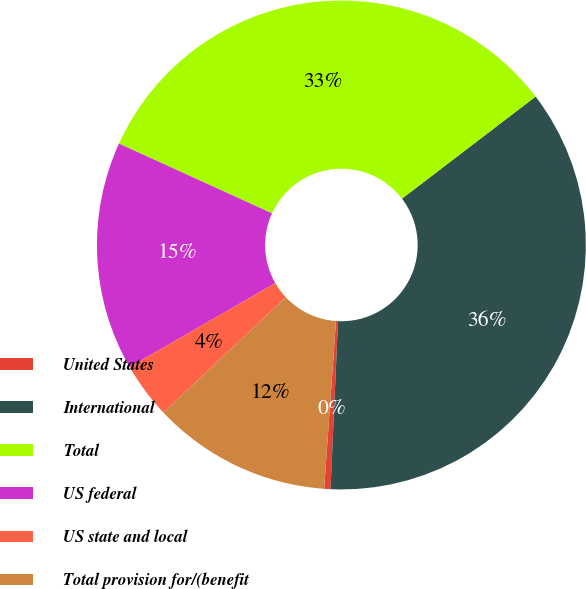Convert chart to OTSL. <chart><loc_0><loc_0><loc_500><loc_500><pie_chart><fcel>United States<fcel>International<fcel>Total<fcel>US federal<fcel>US state and local<fcel>Total provision for/(benefit<nl><fcel>0.42%<fcel>36.09%<fcel>32.81%<fcel>15.13%<fcel>3.7%<fcel>11.85%<nl></chart> 